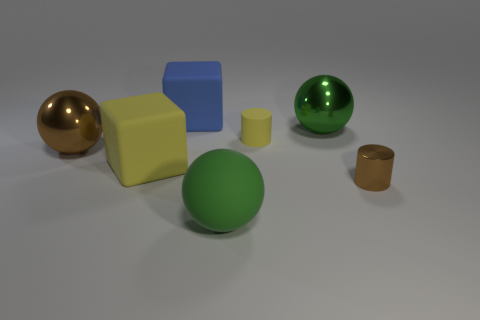The object that is the same color as the matte cylinder is what shape?
Provide a short and direct response. Cube. What is the size of the rubber block that is the same color as the tiny matte object?
Give a very brief answer. Large. What color is the matte ball?
Your answer should be compact. Green. What is the size of the brown object on the right side of the big green sphere that is to the left of the small cylinder that is behind the large yellow cube?
Provide a short and direct response. Small. What number of other objects are there of the same shape as the green shiny thing?
Make the answer very short. 2. The metal object that is both to the right of the big yellow matte object and on the left side of the tiny metallic thing is what color?
Your answer should be compact. Green. Are there any other things that have the same size as the brown shiny sphere?
Your answer should be very brief. Yes. There is a shiny object that is on the right side of the large green shiny object; is it the same color as the tiny rubber cylinder?
Give a very brief answer. No. How many blocks are large blue objects or small matte objects?
Your answer should be compact. 1. What is the shape of the brown object to the right of the brown sphere?
Provide a succinct answer. Cylinder. 